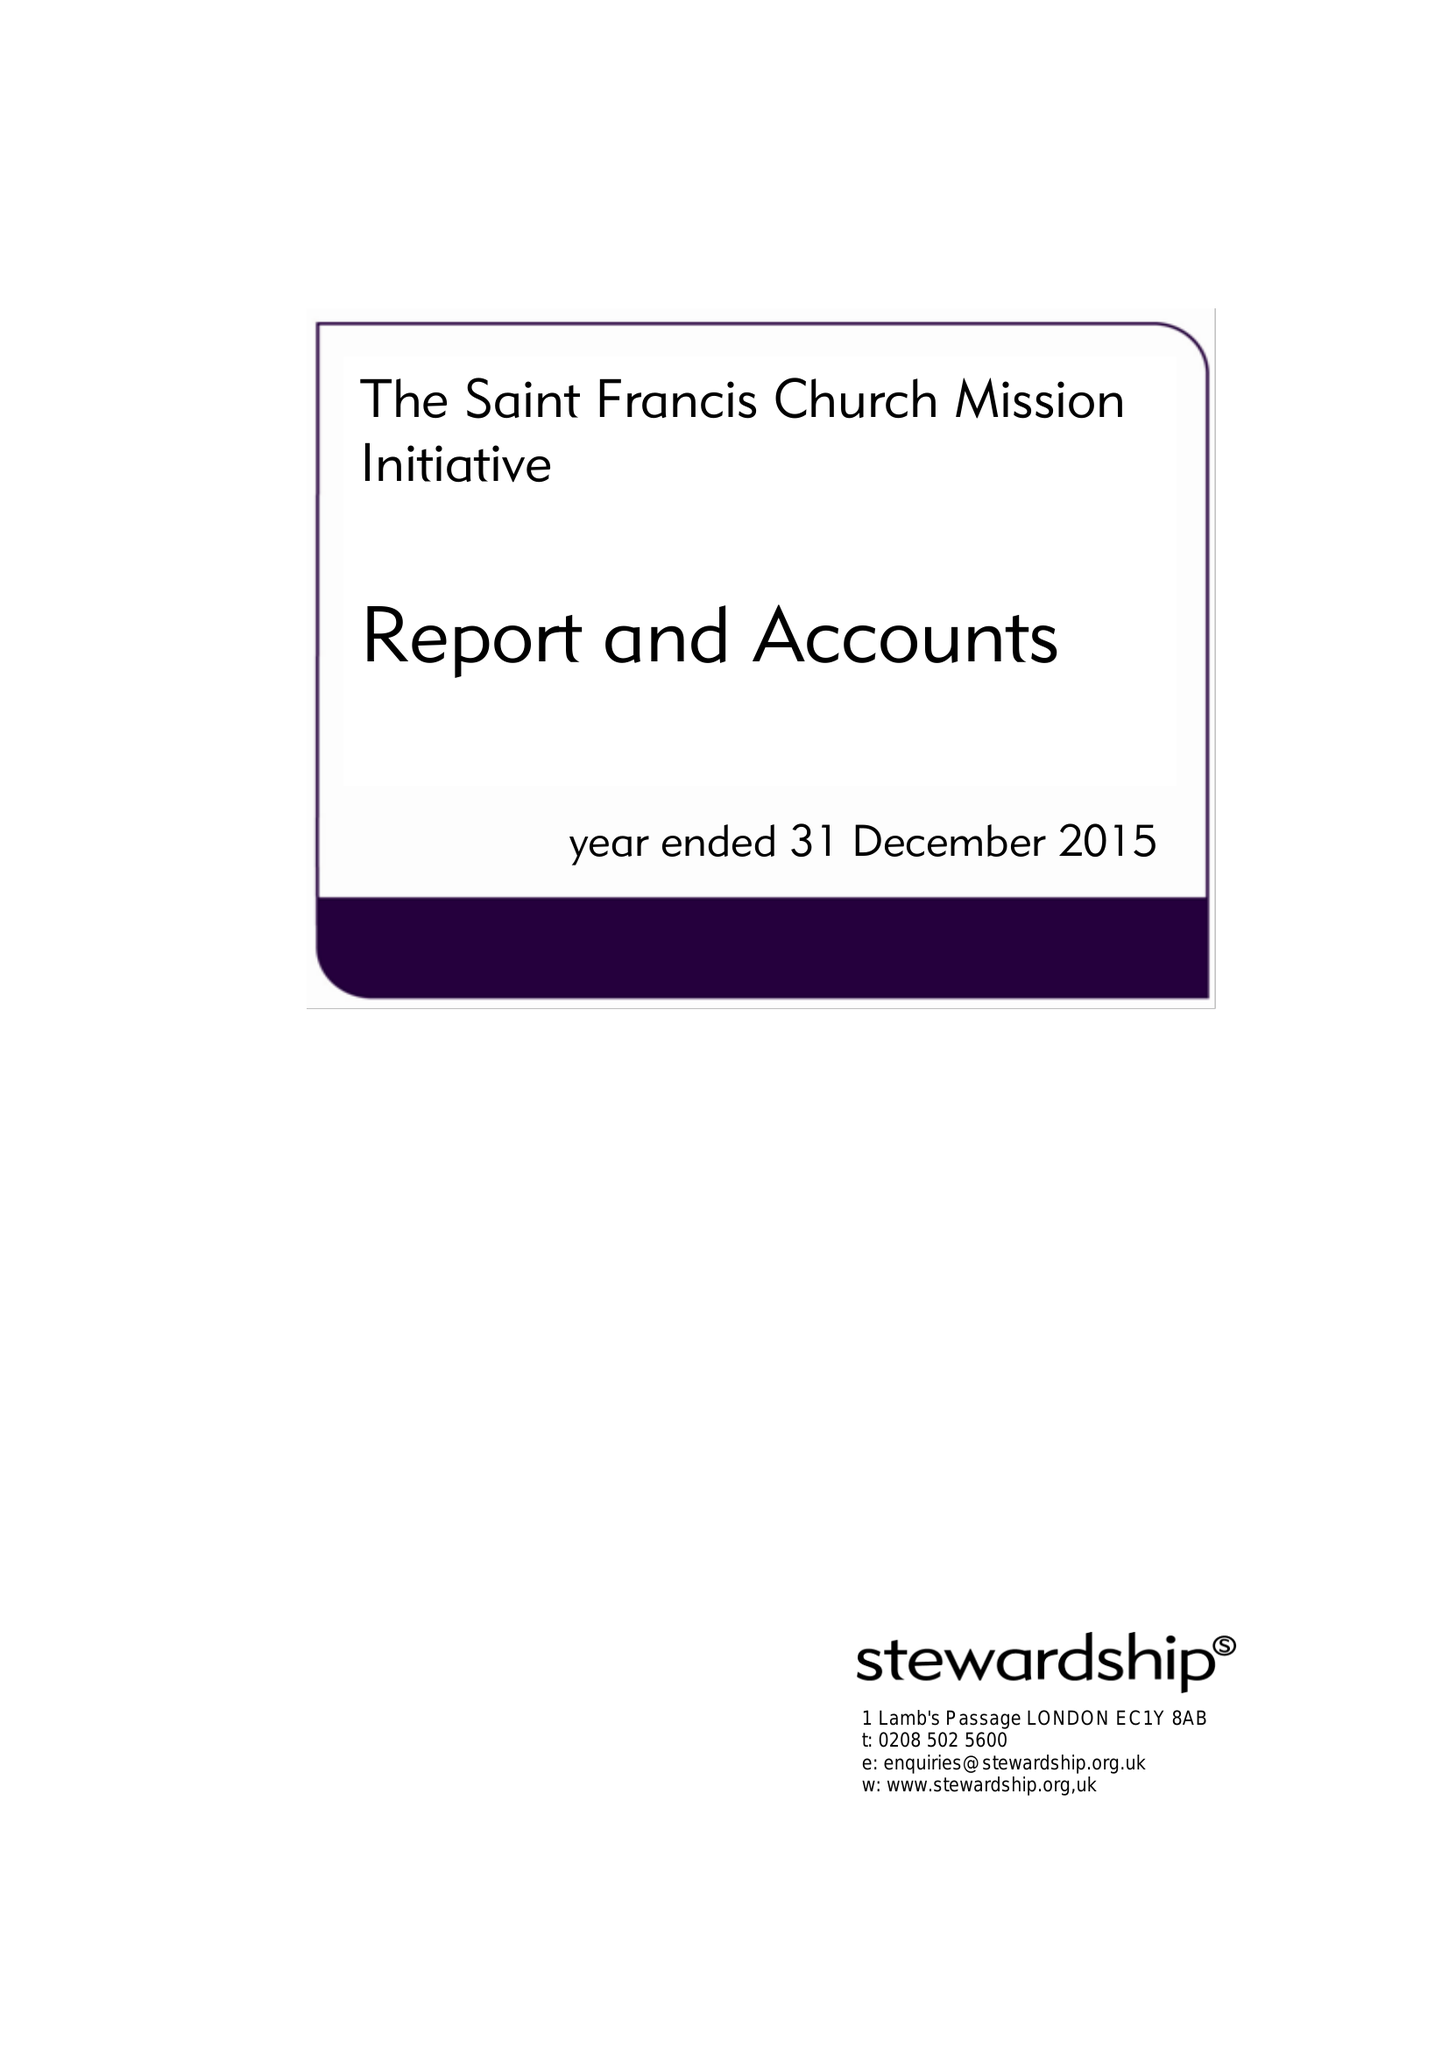What is the value for the charity_number?
Answer the question using a single word or phrase. 1156753 